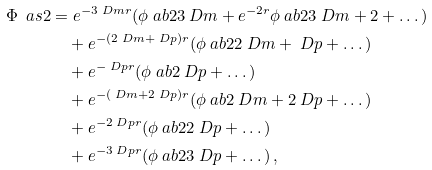<formula> <loc_0><loc_0><loc_500><loc_500>\Phi \ a s { 2 } & = e ^ { - 3 \ D m r } ( \phi \ a b { 2 } { 3 \ D m } + e ^ { - 2 r } \phi \ a b { 2 } { 3 \ D m + 2 } + \dots ) \\ & \quad + e ^ { - ( 2 \ D m + \ D p ) r } ( \phi \ a b { 2 } { 2 \ D m + \ D p } + \dots ) \\ & \quad + e ^ { - \ D p r } ( \phi \ a b { 2 } { \ D p } + \dots ) \\ & \quad + e ^ { - ( \ D m + 2 \ D p ) r } ( \phi \ a b { 2 } { \ D m + 2 \ D p } + \dots ) \\ & \quad + e ^ { - 2 \ D p r } ( \phi \ a b { 2 } { 2 \ D p } + \dots ) \\ & \quad + e ^ { - 3 \ D p r } ( \phi \ a b { 2 } { 3 \ D p } + \dots ) \, ,</formula> 